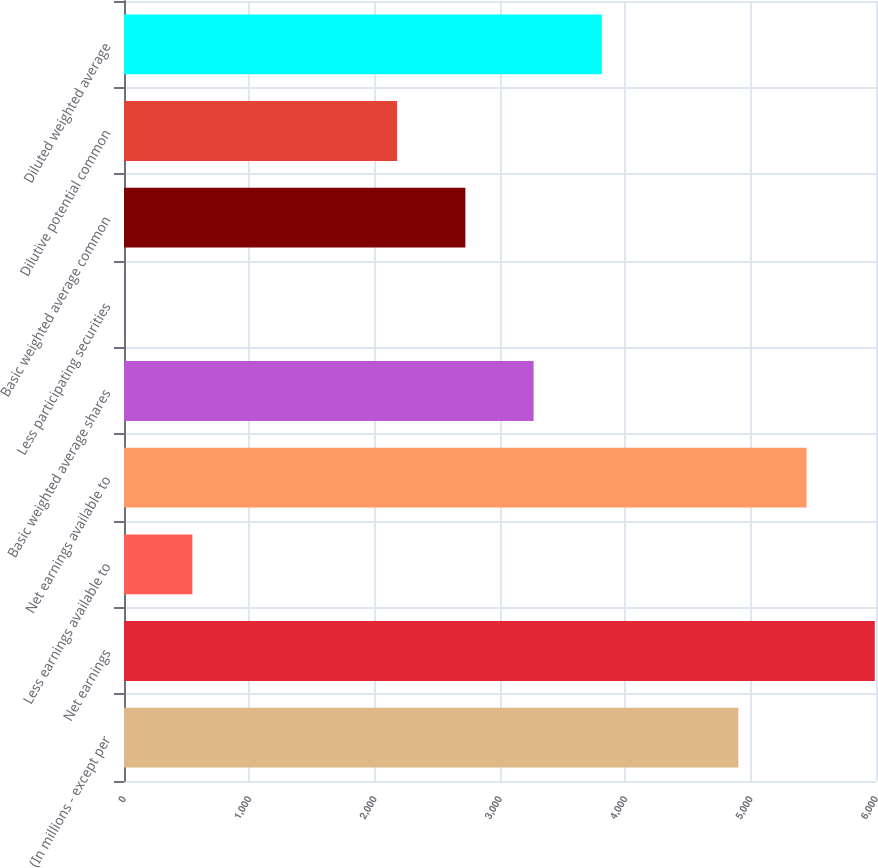<chart> <loc_0><loc_0><loc_500><loc_500><bar_chart><fcel>(In millions - except per<fcel>Net earnings<fcel>Less earnings available to<fcel>Net earnings available to<fcel>Basic weighted average shares<fcel>Less participating securities<fcel>Basic weighted average common<fcel>Dilutive potential common<fcel>Diluted weighted average<nl><fcel>4901.53<fcel>5990.47<fcel>545.77<fcel>5446<fcel>3268.12<fcel>1.3<fcel>2723.65<fcel>2179.18<fcel>3812.59<nl></chart> 